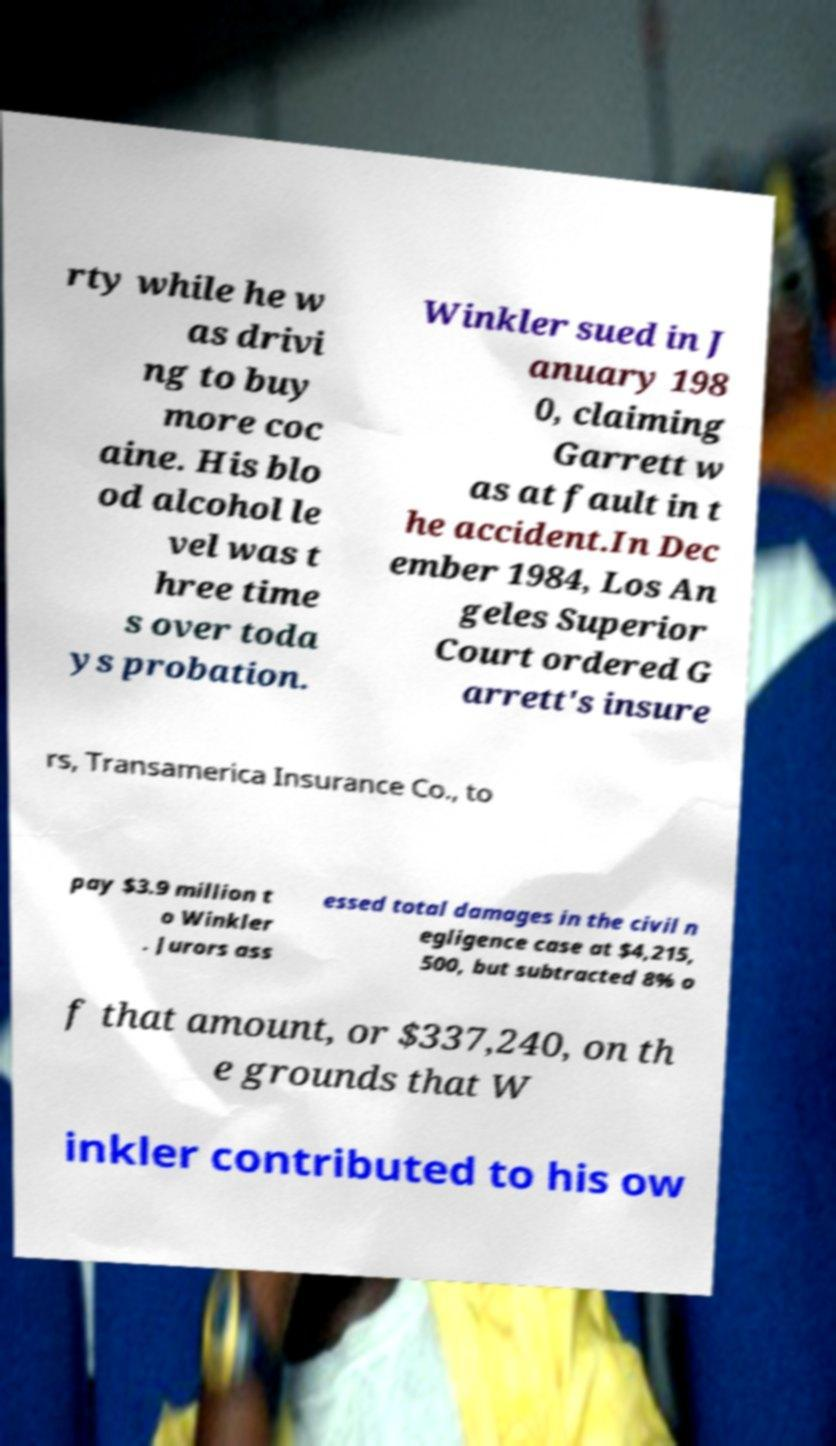There's text embedded in this image that I need extracted. Can you transcribe it verbatim? rty while he w as drivi ng to buy more coc aine. His blo od alcohol le vel was t hree time s over toda ys probation. Winkler sued in J anuary 198 0, claiming Garrett w as at fault in t he accident.In Dec ember 1984, Los An geles Superior Court ordered G arrett's insure rs, Transamerica Insurance Co., to pay $3.9 million t o Winkler . Jurors ass essed total damages in the civil n egligence case at $4,215, 500, but subtracted 8% o f that amount, or $337,240, on th e grounds that W inkler contributed to his ow 